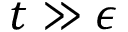<formula> <loc_0><loc_0><loc_500><loc_500>t \gg \epsilon</formula> 